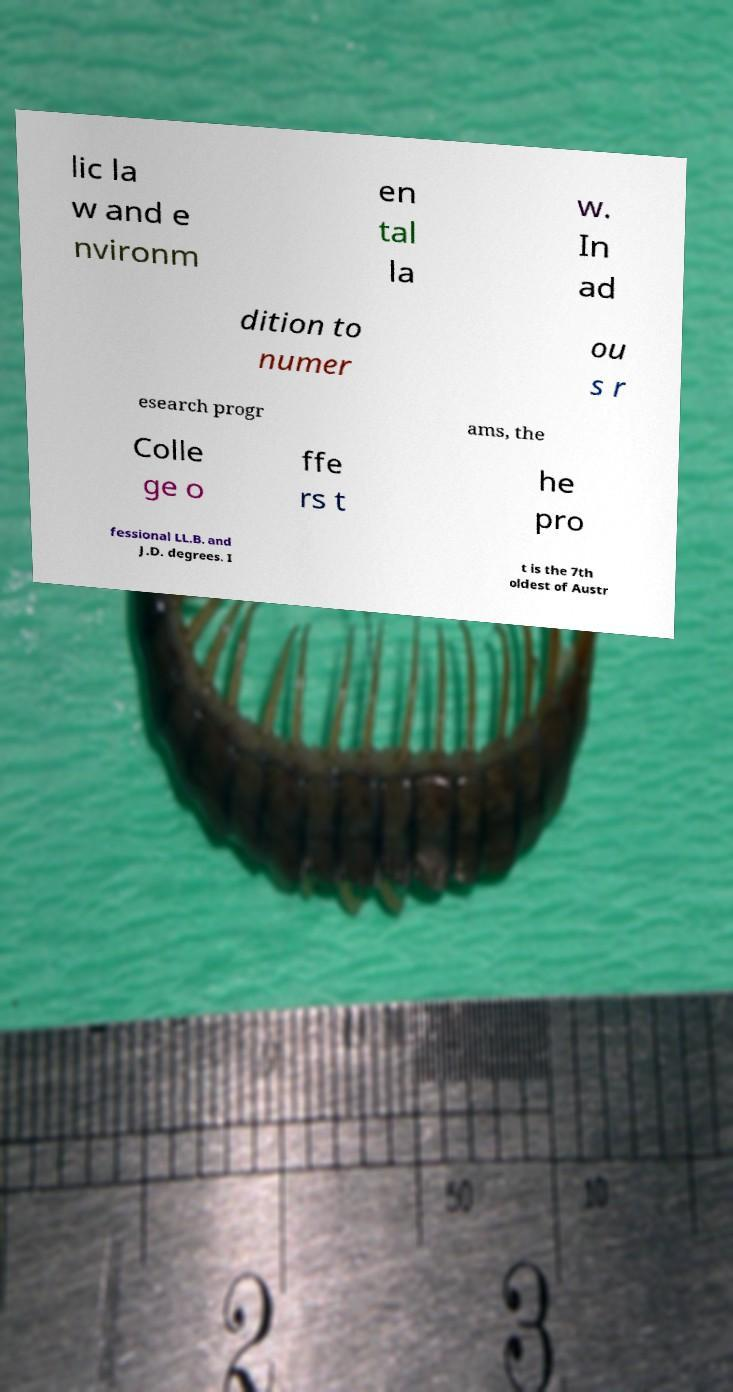There's text embedded in this image that I need extracted. Can you transcribe it verbatim? lic la w and e nvironm en tal la w. In ad dition to numer ou s r esearch progr ams, the Colle ge o ffe rs t he pro fessional LL.B. and J.D. degrees. I t is the 7th oldest of Austr 